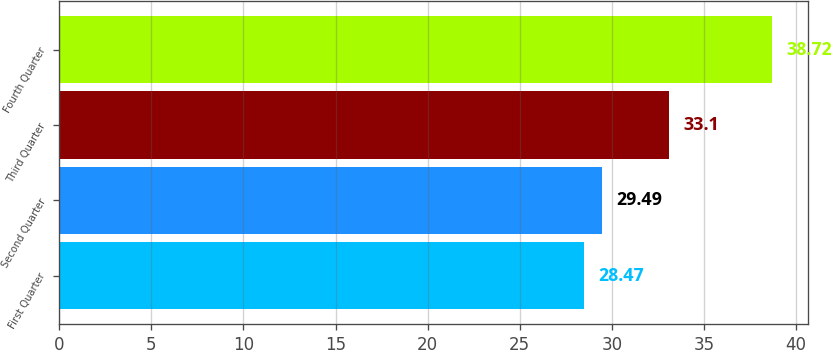Convert chart. <chart><loc_0><loc_0><loc_500><loc_500><bar_chart><fcel>First Quarter<fcel>Second Quarter<fcel>Third Quarter<fcel>Fourth Quarter<nl><fcel>28.47<fcel>29.49<fcel>33.1<fcel>38.72<nl></chart> 